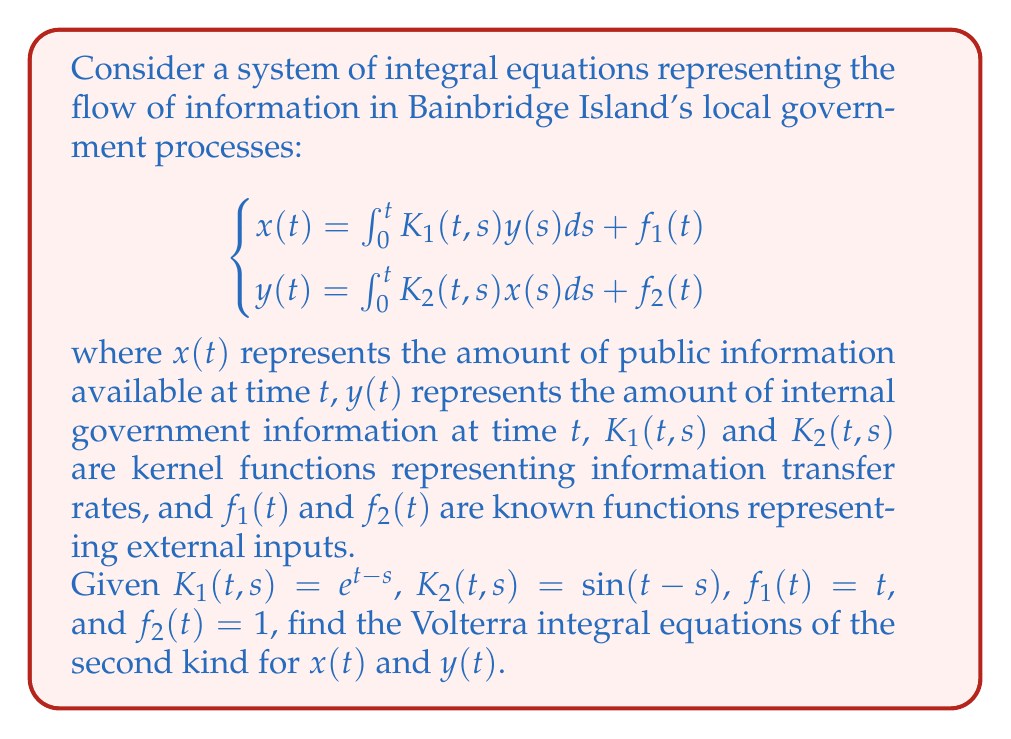Could you help me with this problem? To solve this problem, we need to follow these steps:

1) First, we substitute the given equation for $y(t)$ into the equation for $x(t)$:

   $$x(t) = \int_0^t K_1(t,s)\left(\int_0^s K_2(s,u)x(u)du + f_2(s)\right)ds + f_1(t)$$

2) Now we substitute the given functions:

   $$x(t) = \int_0^t e^{t-s}\left(\int_0^s \sin(s-u)x(u)du + 1\right)ds + t$$

3) We can simplify this equation:

   $$x(t) = \int_0^t e^{t-s}\int_0^s \sin(s-u)x(u)du ds + \int_0^t e^{t-s}ds + t$$

4) The second integral can be evaluated:

   $$\int_0^t e^{t-s}ds = -e^{t-s}|_0^t = -(e^0 - e^t) = e^t - 1$$

5) So our equation for $x(t)$ becomes:

   $$x(t) = \int_0^t e^{t-s}\int_0^s \sin(s-u)x(u)du ds + e^t - 1 + t$$

6) This is a Volterra integral equation of the second kind for $x(t)$.

7) For $y(t)$, we substitute the original equation for $x(t)$ into the equation for $y(t)$:

   $$y(t) = \int_0^t K_2(t,s)\left(\int_0^s K_1(s,u)y(u)du + f_1(s)\right)ds + f_2(t)$$

8) Substituting the given functions:

   $$y(t) = \int_0^t \sin(t-s)\left(\int_0^s e^{s-u}y(u)du + s\right)ds + 1$$

9) This is already in the form of a Volterra integral equation of the second kind for $y(t)$.
Answer: $$x(t) = \int_0^t e^{t-s}\int_0^s \sin(s-u)x(u)du ds + e^t - 1 + t$$
$$y(t) = \int_0^t \sin(t-s)\left(\int_0^s e^{s-u}y(u)du + s\right)ds + 1$$ 